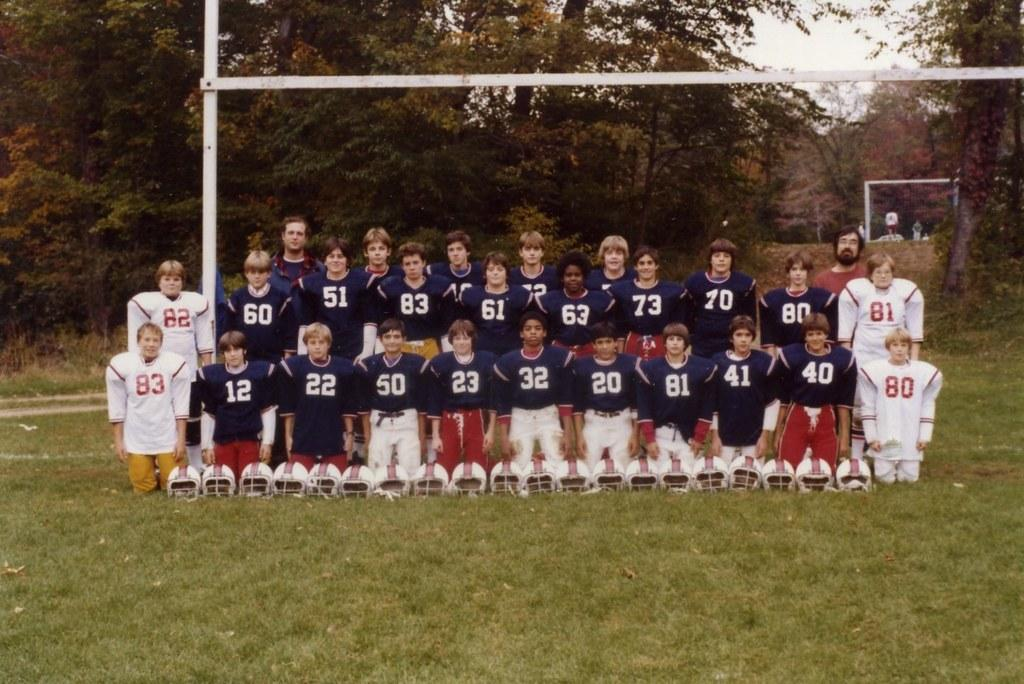<image>
Write a terse but informative summary of the picture. The boy wearing the number 83 poses with his football team. 